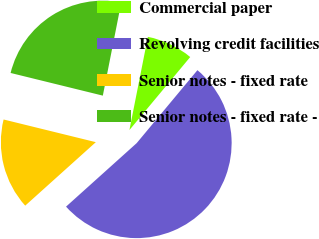Convert chart. <chart><loc_0><loc_0><loc_500><loc_500><pie_chart><fcel>Commercial paper<fcel>Revolving credit facilities<fcel>Senior notes - fixed rate<fcel>Senior notes - fixed rate -<nl><fcel>7.94%<fcel>52.29%<fcel>15.49%<fcel>24.27%<nl></chart> 